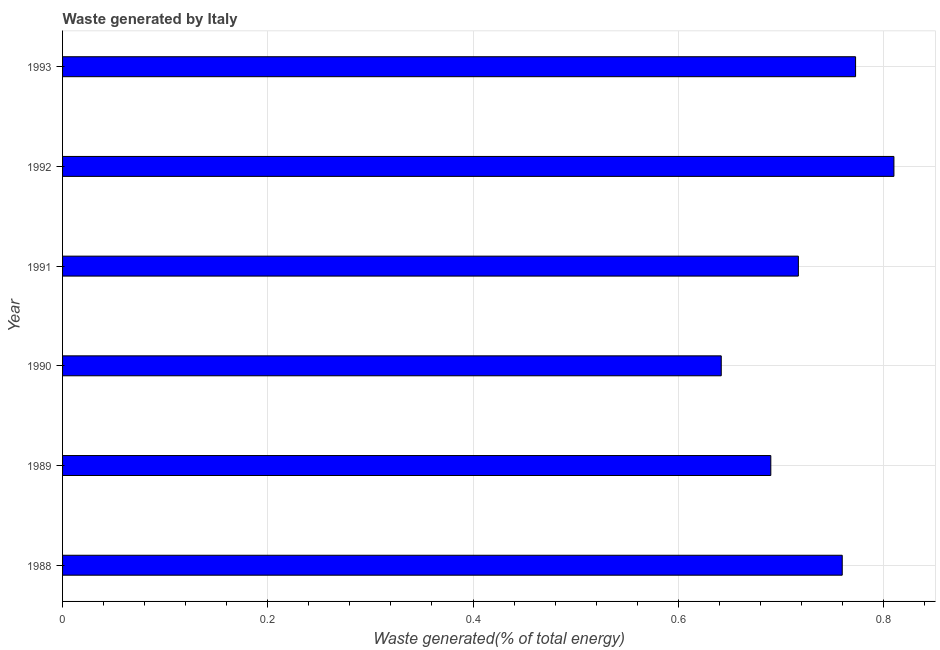What is the title of the graph?
Offer a terse response. Waste generated by Italy. What is the label or title of the X-axis?
Make the answer very short. Waste generated(% of total energy). What is the label or title of the Y-axis?
Provide a succinct answer. Year. What is the amount of waste generated in 1993?
Provide a succinct answer. 0.77. Across all years, what is the maximum amount of waste generated?
Offer a terse response. 0.81. Across all years, what is the minimum amount of waste generated?
Give a very brief answer. 0.64. In which year was the amount of waste generated minimum?
Ensure brevity in your answer.  1990. What is the sum of the amount of waste generated?
Offer a very short reply. 4.39. What is the difference between the amount of waste generated in 1988 and 1993?
Provide a short and direct response. -0.01. What is the average amount of waste generated per year?
Provide a succinct answer. 0.73. What is the median amount of waste generated?
Your response must be concise. 0.74. Do a majority of the years between 1992 and 1988 (inclusive) have amount of waste generated greater than 0.44 %?
Keep it short and to the point. Yes. What is the ratio of the amount of waste generated in 1989 to that in 1992?
Make the answer very short. 0.85. Is the amount of waste generated in 1992 less than that in 1993?
Provide a short and direct response. No. Is the difference between the amount of waste generated in 1991 and 1993 greater than the difference between any two years?
Offer a very short reply. No. What is the difference between the highest and the second highest amount of waste generated?
Make the answer very short. 0.04. Is the sum of the amount of waste generated in 1991 and 1993 greater than the maximum amount of waste generated across all years?
Provide a short and direct response. Yes. What is the difference between the highest and the lowest amount of waste generated?
Provide a short and direct response. 0.17. In how many years, is the amount of waste generated greater than the average amount of waste generated taken over all years?
Ensure brevity in your answer.  3. How many bars are there?
Your answer should be compact. 6. How many years are there in the graph?
Your answer should be compact. 6. Are the values on the major ticks of X-axis written in scientific E-notation?
Provide a short and direct response. No. What is the Waste generated(% of total energy) of 1988?
Offer a terse response. 0.76. What is the Waste generated(% of total energy) in 1989?
Your answer should be compact. 0.69. What is the Waste generated(% of total energy) of 1990?
Offer a very short reply. 0.64. What is the Waste generated(% of total energy) in 1991?
Keep it short and to the point. 0.72. What is the Waste generated(% of total energy) of 1992?
Offer a terse response. 0.81. What is the Waste generated(% of total energy) of 1993?
Ensure brevity in your answer.  0.77. What is the difference between the Waste generated(% of total energy) in 1988 and 1989?
Keep it short and to the point. 0.07. What is the difference between the Waste generated(% of total energy) in 1988 and 1990?
Make the answer very short. 0.12. What is the difference between the Waste generated(% of total energy) in 1988 and 1991?
Offer a terse response. 0.04. What is the difference between the Waste generated(% of total energy) in 1988 and 1992?
Ensure brevity in your answer.  -0.05. What is the difference between the Waste generated(% of total energy) in 1988 and 1993?
Your answer should be very brief. -0.01. What is the difference between the Waste generated(% of total energy) in 1989 and 1990?
Your response must be concise. 0.05. What is the difference between the Waste generated(% of total energy) in 1989 and 1991?
Your answer should be compact. -0.03. What is the difference between the Waste generated(% of total energy) in 1989 and 1992?
Make the answer very short. -0.12. What is the difference between the Waste generated(% of total energy) in 1989 and 1993?
Provide a short and direct response. -0.08. What is the difference between the Waste generated(% of total energy) in 1990 and 1991?
Offer a very short reply. -0.08. What is the difference between the Waste generated(% of total energy) in 1990 and 1992?
Offer a very short reply. -0.17. What is the difference between the Waste generated(% of total energy) in 1990 and 1993?
Give a very brief answer. -0.13. What is the difference between the Waste generated(% of total energy) in 1991 and 1992?
Your answer should be compact. -0.09. What is the difference between the Waste generated(% of total energy) in 1991 and 1993?
Ensure brevity in your answer.  -0.06. What is the difference between the Waste generated(% of total energy) in 1992 and 1993?
Offer a very short reply. 0.04. What is the ratio of the Waste generated(% of total energy) in 1988 to that in 1989?
Your answer should be very brief. 1.1. What is the ratio of the Waste generated(% of total energy) in 1988 to that in 1990?
Offer a very short reply. 1.18. What is the ratio of the Waste generated(% of total energy) in 1988 to that in 1991?
Offer a very short reply. 1.06. What is the ratio of the Waste generated(% of total energy) in 1988 to that in 1992?
Provide a short and direct response. 0.94. What is the ratio of the Waste generated(% of total energy) in 1989 to that in 1990?
Keep it short and to the point. 1.07. What is the ratio of the Waste generated(% of total energy) in 1989 to that in 1992?
Keep it short and to the point. 0.85. What is the ratio of the Waste generated(% of total energy) in 1989 to that in 1993?
Provide a succinct answer. 0.89. What is the ratio of the Waste generated(% of total energy) in 1990 to that in 1991?
Provide a short and direct response. 0.9. What is the ratio of the Waste generated(% of total energy) in 1990 to that in 1992?
Ensure brevity in your answer.  0.79. What is the ratio of the Waste generated(% of total energy) in 1990 to that in 1993?
Offer a terse response. 0.83. What is the ratio of the Waste generated(% of total energy) in 1991 to that in 1992?
Keep it short and to the point. 0.89. What is the ratio of the Waste generated(% of total energy) in 1991 to that in 1993?
Offer a terse response. 0.93. What is the ratio of the Waste generated(% of total energy) in 1992 to that in 1993?
Your answer should be compact. 1.05. 